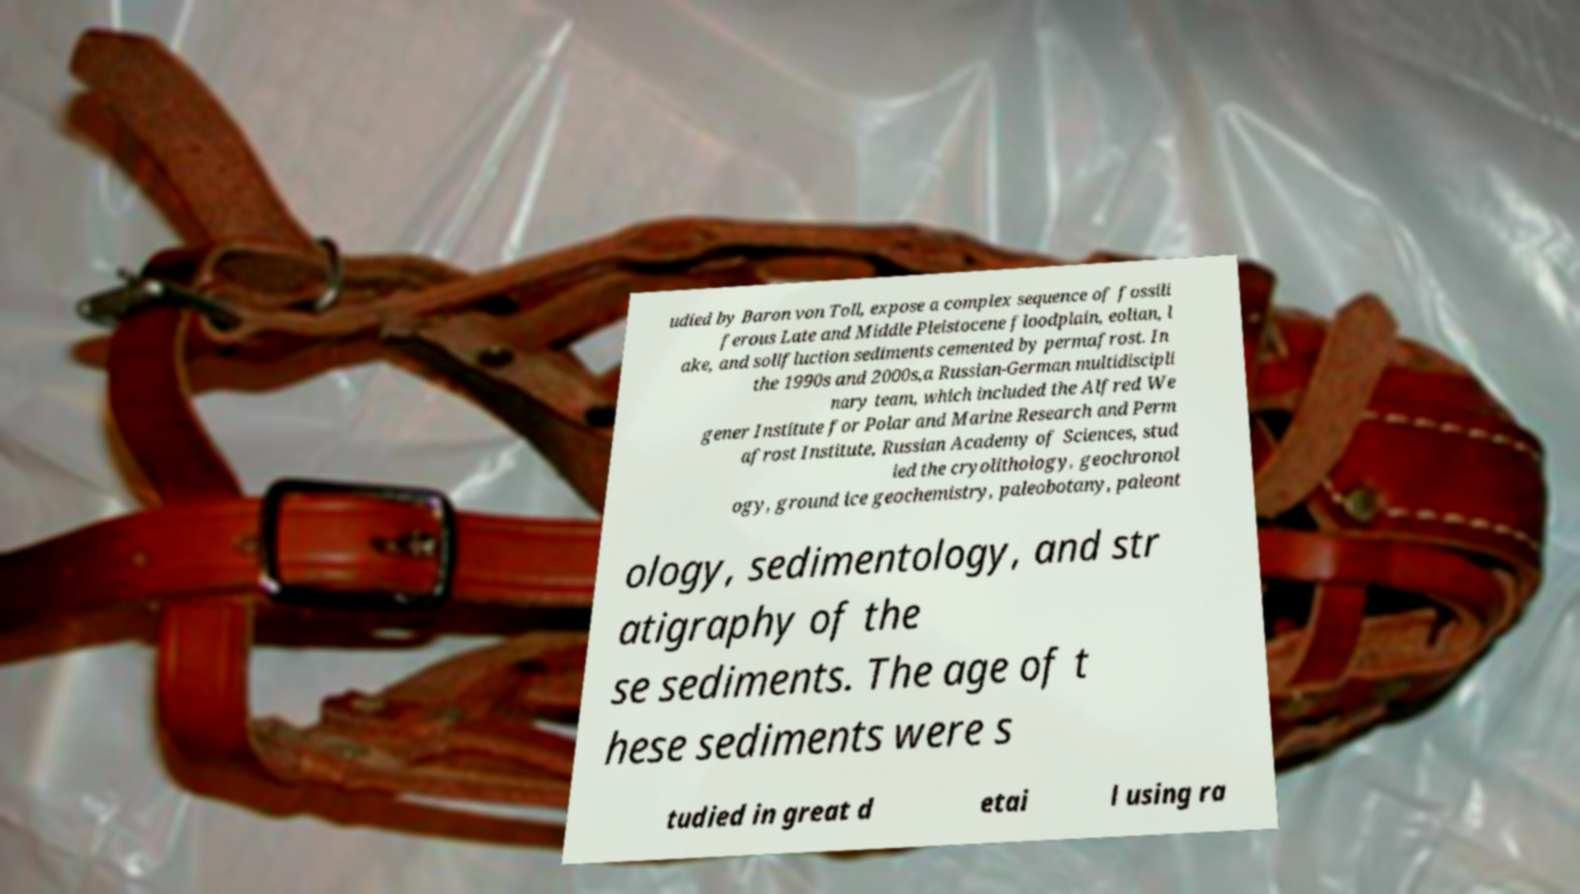What messages or text are displayed in this image? I need them in a readable, typed format. udied by Baron von Toll, expose a complex sequence of fossili ferous Late and Middle Pleistocene floodplain, eolian, l ake, and solifluction sediments cemented by permafrost. In the 1990s and 2000s,a Russian-German multidiscipli nary team, which included the Alfred We gener Institute for Polar and Marine Research and Perm afrost Institute, Russian Academy of Sciences, stud ied the cryolithology, geochronol ogy, ground ice geochemistry, paleobotany, paleont ology, sedimentology, and str atigraphy of the se sediments. The age of t hese sediments were s tudied in great d etai l using ra 